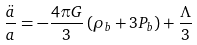<formula> <loc_0><loc_0><loc_500><loc_500>\frac { \ddot { a } } { a } = - \frac { 4 \pi G } { 3 } \left ( \rho _ { b } + { 3 P _ { b } } \right ) + \frac { \Lambda } { 3 }</formula> 